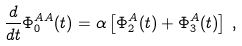Convert formula to latex. <formula><loc_0><loc_0><loc_500><loc_500>\frac { d } { d t } \Phi _ { 0 } ^ { A A } ( t ) = \alpha \left [ \Phi _ { 2 } ^ { A } ( t ) + \Phi _ { 3 } ^ { A } ( t ) \right ] \, ,</formula> 